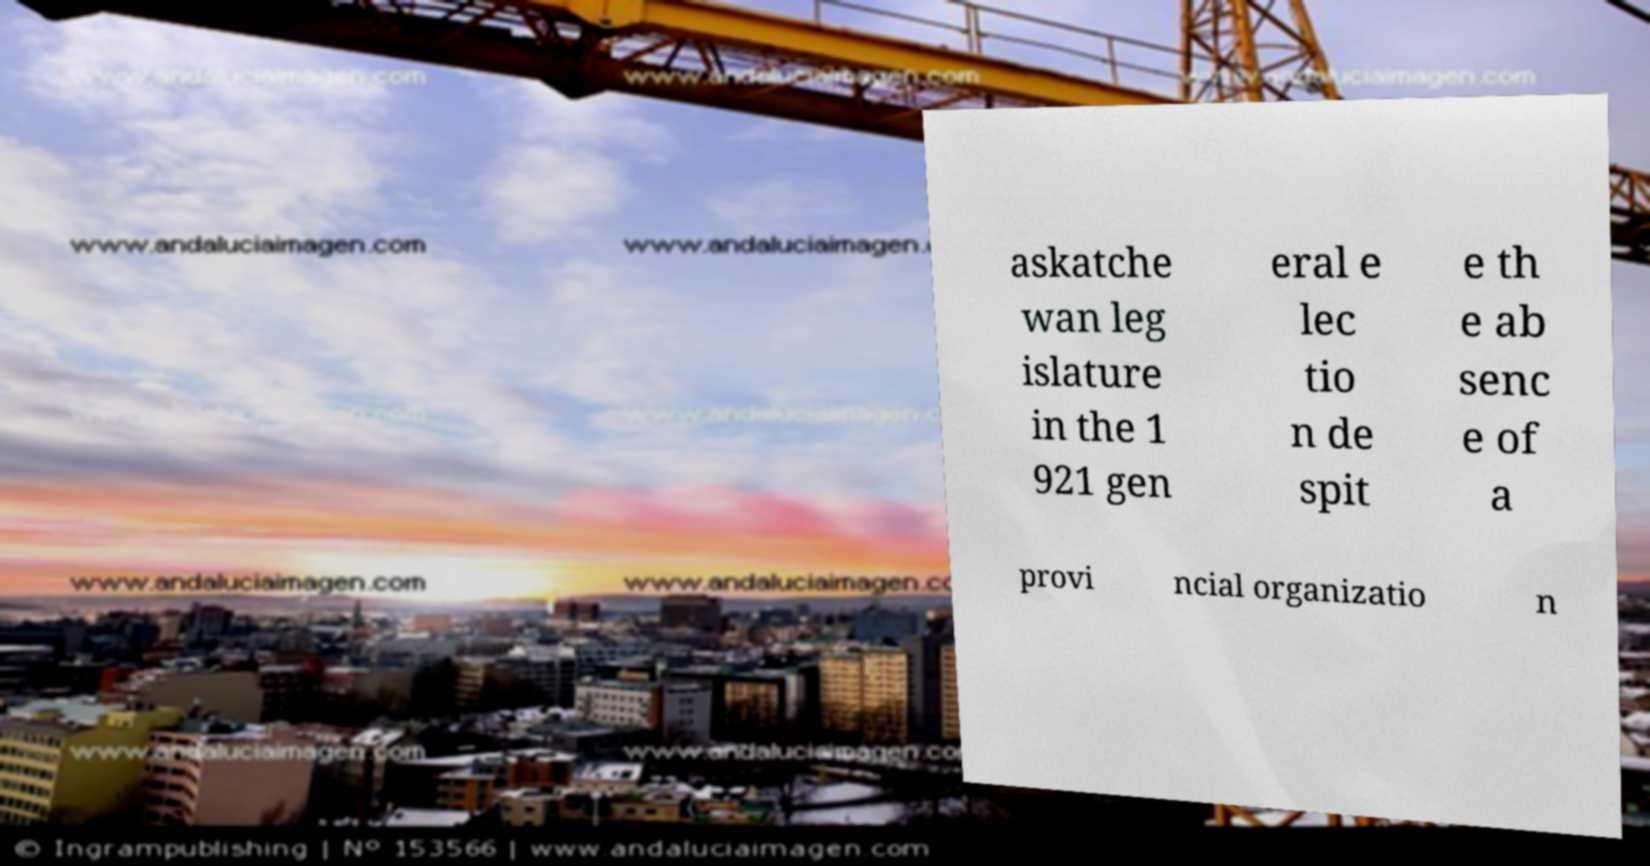Please read and relay the text visible in this image. What does it say? askatche wan leg islature in the 1 921 gen eral e lec tio n de spit e th e ab senc e of a provi ncial organizatio n 